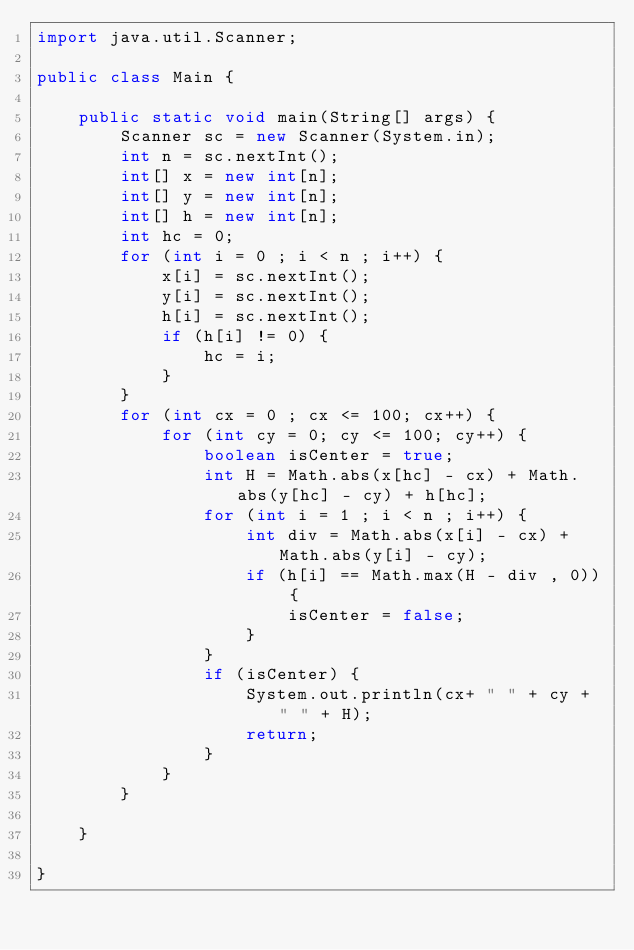<code> <loc_0><loc_0><loc_500><loc_500><_Java_>import java.util.Scanner;

public class Main {

    public static void main(String[] args) {
        Scanner sc = new Scanner(System.in);
        int n = sc.nextInt();
        int[] x = new int[n];
        int[] y = new int[n];
        int[] h = new int[n];
        int hc = 0;
        for (int i = 0 ; i < n ; i++) {
            x[i] = sc.nextInt();
            y[i] = sc.nextInt();
            h[i] = sc.nextInt();
            if (h[i] != 0) {
                hc = i;
            }
        }
        for (int cx = 0 ; cx <= 100; cx++) {
            for (int cy = 0; cy <= 100; cy++) {
                boolean isCenter = true;
                int H = Math.abs(x[hc] - cx) + Math.abs(y[hc] - cy) + h[hc];
                for (int i = 1 ; i < n ; i++) {
                    int div = Math.abs(x[i] - cx) + Math.abs(y[i] - cy);
                    if (h[i] == Math.max(H - div , 0)) {
                        isCenter = false;
                    }
                }
                if (isCenter) {
                    System.out.println(cx+ " " + cy + " " + H);
                    return;
                }
            }
        }

    }

}</code> 